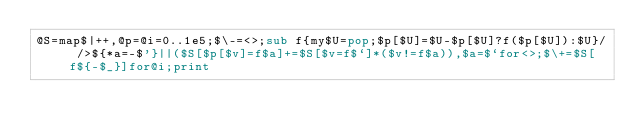Convert code to text. <code><loc_0><loc_0><loc_500><loc_500><_Perl_>@S=map$|++,@p=@i=0..1e5;$\-=<>;sub f{my$U=pop;$p[$U]=$U-$p[$U]?f($p[$U]):$U}/ />${*a=-$'}||($S[$p[$v]=f$a]+=$S[$v=f$`]*($v!=f$a)),$a=$`for<>;$\+=$S[f${-$_}]for@i;print</code> 